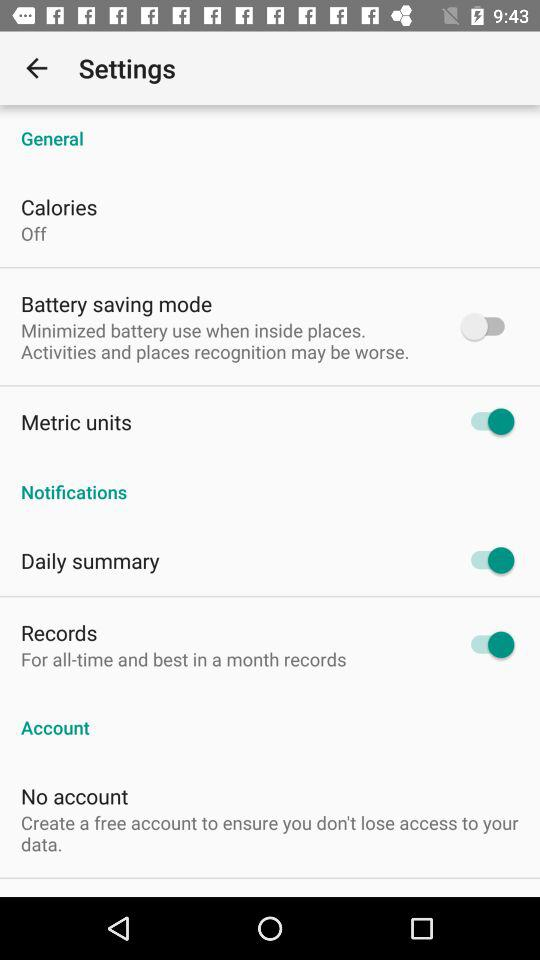What is the status of "Daily summary" notification? The status is "on". 